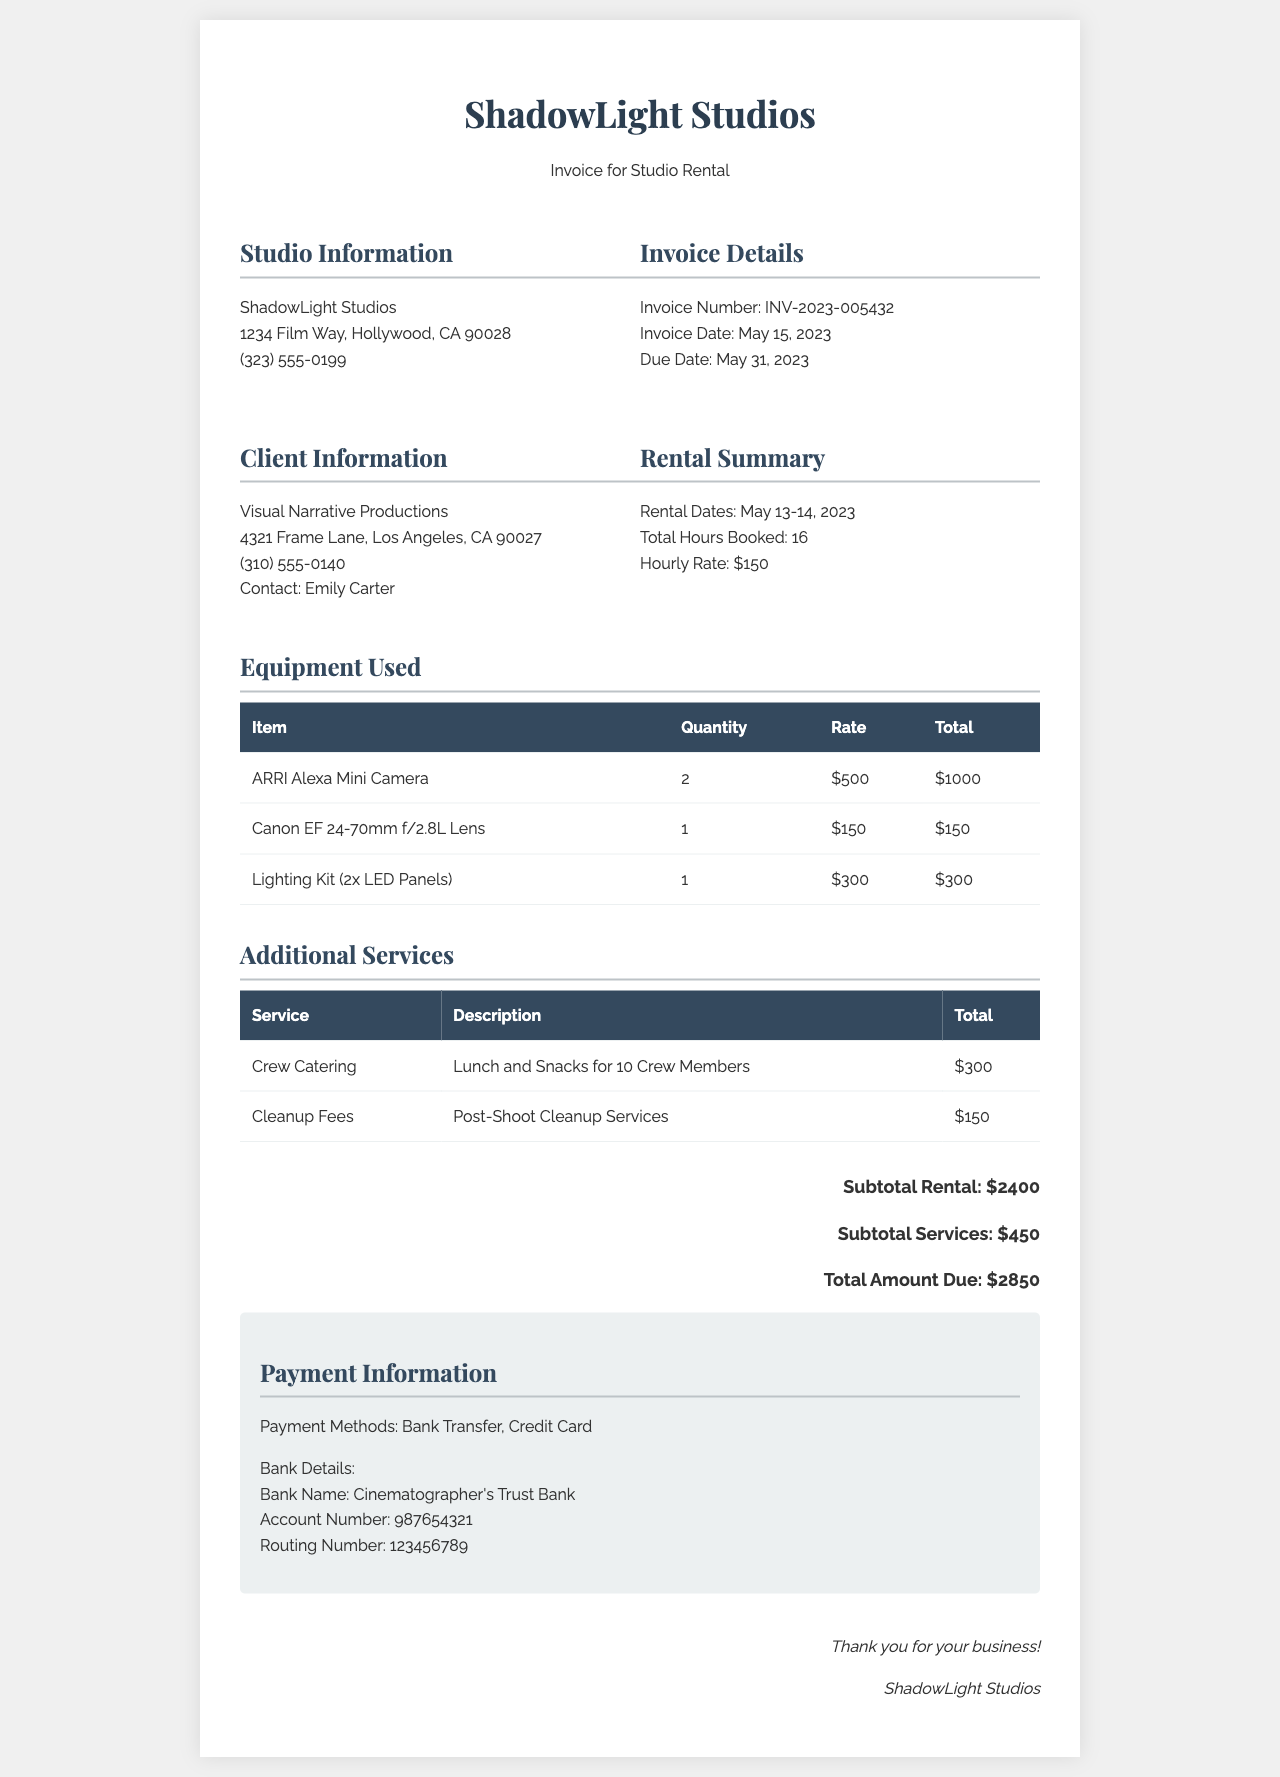what is the total hours booked? The total hours booked are specified in the rental summary section of the invoice.
Answer: 16 who is the contact for the client? The contact person for Visual Narrative Productions is listed under client information.
Answer: Emily Carter what is the hourly rate for the studio rental? The hourly rate is provided in the rental summary of the document.
Answer: $150 what is the total amount due? The total amount due is presented in the total section at the end of the invoice.
Answer: $2850 how many ARRI Alexa Mini Cameras were used? The quantity of ARRI Alexa Mini Cameras is noted in the equipment used section of the invoice.
Answer: 2 what services are included under additional services? This asks for a summary of the services provided along with their descriptions, found in the respective section.
Answer: Crew Catering, Cleanup Fees what are the rental dates? The rental dates are outlined in the rental summary section of the invoice.
Answer: May 13-14, 2023 what type of payment methods are accepted? The payment methods are described in the payment information section of the invoice.
Answer: Bank Transfer, Credit Card what is the subtotal for rental? The subtotal for rental is provided in the total section of the document.
Answer: $2400 